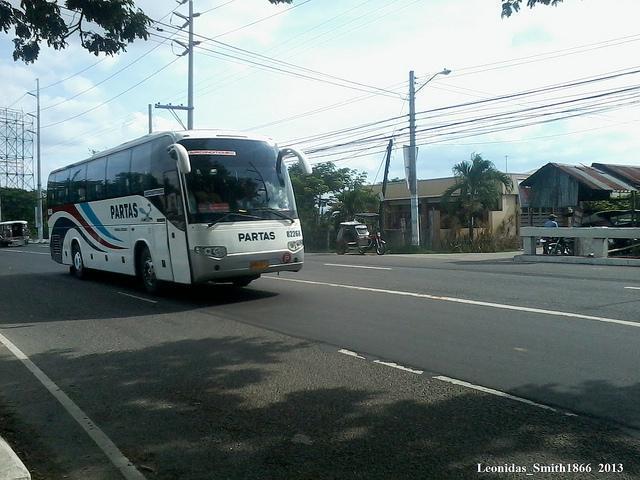What type of lines are located above the street?
Answer the question by selecting the correct answer among the 4 following choices.
Options: Cell, power, water, sewage. Power. 